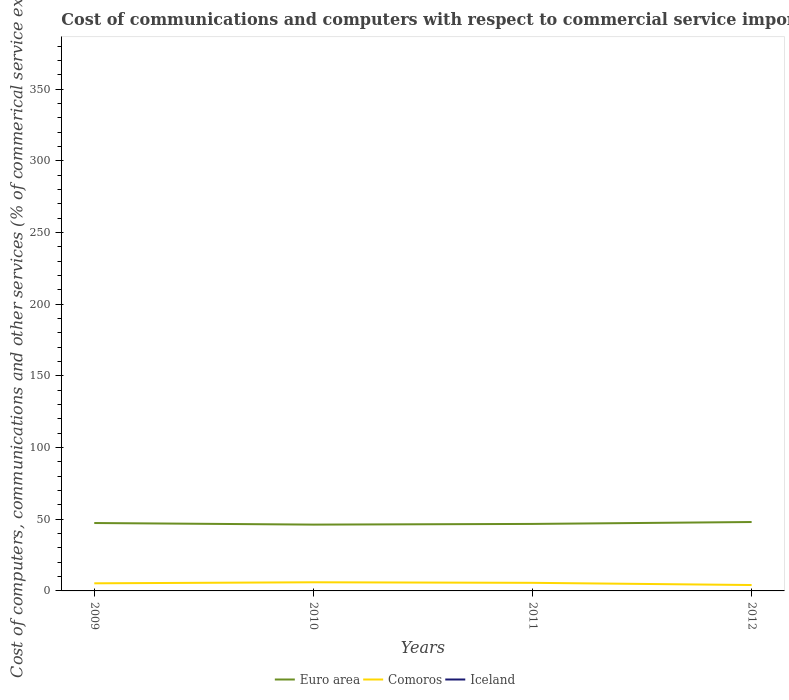Does the line corresponding to Iceland intersect with the line corresponding to Euro area?
Keep it short and to the point. No. Across all years, what is the maximum cost of communications and computers in Iceland?
Provide a short and direct response. 0. What is the total cost of communications and computers in Euro area in the graph?
Offer a very short reply. -0.49. What is the difference between the highest and the second highest cost of communications and computers in Comoros?
Your answer should be very brief. 1.92. Is the cost of communications and computers in Iceland strictly greater than the cost of communications and computers in Comoros over the years?
Offer a very short reply. Yes. How many lines are there?
Your response must be concise. 2. What is the difference between two consecutive major ticks on the Y-axis?
Give a very brief answer. 50. Are the values on the major ticks of Y-axis written in scientific E-notation?
Keep it short and to the point. No. Does the graph contain any zero values?
Keep it short and to the point. Yes. Does the graph contain grids?
Ensure brevity in your answer.  No. Where does the legend appear in the graph?
Offer a very short reply. Bottom center. How many legend labels are there?
Provide a short and direct response. 3. How are the legend labels stacked?
Keep it short and to the point. Horizontal. What is the title of the graph?
Your answer should be compact. Cost of communications and computers with respect to commercial service imports. What is the label or title of the Y-axis?
Your answer should be very brief. Cost of computers, communications and other services (% of commerical service exports). What is the Cost of computers, communications and other services (% of commerical service exports) of Euro area in 2009?
Make the answer very short. 47.36. What is the Cost of computers, communications and other services (% of commerical service exports) in Comoros in 2009?
Make the answer very short. 5.31. What is the Cost of computers, communications and other services (% of commerical service exports) in Iceland in 2009?
Your answer should be very brief. 0. What is the Cost of computers, communications and other services (% of commerical service exports) in Euro area in 2010?
Your answer should be compact. 46.25. What is the Cost of computers, communications and other services (% of commerical service exports) of Comoros in 2010?
Give a very brief answer. 6.03. What is the Cost of computers, communications and other services (% of commerical service exports) in Iceland in 2010?
Give a very brief answer. 0. What is the Cost of computers, communications and other services (% of commerical service exports) in Euro area in 2011?
Ensure brevity in your answer.  46.73. What is the Cost of computers, communications and other services (% of commerical service exports) of Comoros in 2011?
Provide a short and direct response. 5.64. What is the Cost of computers, communications and other services (% of commerical service exports) of Euro area in 2012?
Make the answer very short. 48.05. What is the Cost of computers, communications and other services (% of commerical service exports) in Comoros in 2012?
Provide a succinct answer. 4.11. Across all years, what is the maximum Cost of computers, communications and other services (% of commerical service exports) in Euro area?
Your answer should be very brief. 48.05. Across all years, what is the maximum Cost of computers, communications and other services (% of commerical service exports) in Comoros?
Provide a short and direct response. 6.03. Across all years, what is the minimum Cost of computers, communications and other services (% of commerical service exports) of Euro area?
Provide a succinct answer. 46.25. Across all years, what is the minimum Cost of computers, communications and other services (% of commerical service exports) in Comoros?
Your response must be concise. 4.11. What is the total Cost of computers, communications and other services (% of commerical service exports) of Euro area in the graph?
Ensure brevity in your answer.  188.39. What is the total Cost of computers, communications and other services (% of commerical service exports) of Comoros in the graph?
Keep it short and to the point. 21.09. What is the difference between the Cost of computers, communications and other services (% of commerical service exports) in Euro area in 2009 and that in 2010?
Ensure brevity in your answer.  1.11. What is the difference between the Cost of computers, communications and other services (% of commerical service exports) in Comoros in 2009 and that in 2010?
Give a very brief answer. -0.72. What is the difference between the Cost of computers, communications and other services (% of commerical service exports) of Euro area in 2009 and that in 2011?
Give a very brief answer. 0.62. What is the difference between the Cost of computers, communications and other services (% of commerical service exports) of Comoros in 2009 and that in 2011?
Provide a succinct answer. -0.33. What is the difference between the Cost of computers, communications and other services (% of commerical service exports) in Euro area in 2009 and that in 2012?
Offer a very short reply. -0.7. What is the difference between the Cost of computers, communications and other services (% of commerical service exports) of Comoros in 2009 and that in 2012?
Offer a terse response. 1.2. What is the difference between the Cost of computers, communications and other services (% of commerical service exports) of Euro area in 2010 and that in 2011?
Your response must be concise. -0.49. What is the difference between the Cost of computers, communications and other services (% of commerical service exports) of Comoros in 2010 and that in 2011?
Your answer should be very brief. 0.39. What is the difference between the Cost of computers, communications and other services (% of commerical service exports) in Euro area in 2010 and that in 2012?
Provide a succinct answer. -1.81. What is the difference between the Cost of computers, communications and other services (% of commerical service exports) in Comoros in 2010 and that in 2012?
Offer a terse response. 1.92. What is the difference between the Cost of computers, communications and other services (% of commerical service exports) in Euro area in 2011 and that in 2012?
Keep it short and to the point. -1.32. What is the difference between the Cost of computers, communications and other services (% of commerical service exports) of Comoros in 2011 and that in 2012?
Ensure brevity in your answer.  1.53. What is the difference between the Cost of computers, communications and other services (% of commerical service exports) of Euro area in 2009 and the Cost of computers, communications and other services (% of commerical service exports) of Comoros in 2010?
Provide a succinct answer. 41.33. What is the difference between the Cost of computers, communications and other services (% of commerical service exports) in Euro area in 2009 and the Cost of computers, communications and other services (% of commerical service exports) in Comoros in 2011?
Make the answer very short. 41.72. What is the difference between the Cost of computers, communications and other services (% of commerical service exports) of Euro area in 2009 and the Cost of computers, communications and other services (% of commerical service exports) of Comoros in 2012?
Provide a succinct answer. 43.25. What is the difference between the Cost of computers, communications and other services (% of commerical service exports) in Euro area in 2010 and the Cost of computers, communications and other services (% of commerical service exports) in Comoros in 2011?
Ensure brevity in your answer.  40.61. What is the difference between the Cost of computers, communications and other services (% of commerical service exports) in Euro area in 2010 and the Cost of computers, communications and other services (% of commerical service exports) in Comoros in 2012?
Your answer should be compact. 42.13. What is the difference between the Cost of computers, communications and other services (% of commerical service exports) in Euro area in 2011 and the Cost of computers, communications and other services (% of commerical service exports) in Comoros in 2012?
Offer a very short reply. 42.62. What is the average Cost of computers, communications and other services (% of commerical service exports) of Euro area per year?
Provide a short and direct response. 47.1. What is the average Cost of computers, communications and other services (% of commerical service exports) of Comoros per year?
Your answer should be very brief. 5.27. What is the average Cost of computers, communications and other services (% of commerical service exports) in Iceland per year?
Keep it short and to the point. 0. In the year 2009, what is the difference between the Cost of computers, communications and other services (% of commerical service exports) of Euro area and Cost of computers, communications and other services (% of commerical service exports) of Comoros?
Ensure brevity in your answer.  42.05. In the year 2010, what is the difference between the Cost of computers, communications and other services (% of commerical service exports) of Euro area and Cost of computers, communications and other services (% of commerical service exports) of Comoros?
Your response must be concise. 40.22. In the year 2011, what is the difference between the Cost of computers, communications and other services (% of commerical service exports) of Euro area and Cost of computers, communications and other services (% of commerical service exports) of Comoros?
Give a very brief answer. 41.1. In the year 2012, what is the difference between the Cost of computers, communications and other services (% of commerical service exports) of Euro area and Cost of computers, communications and other services (% of commerical service exports) of Comoros?
Your answer should be compact. 43.94. What is the ratio of the Cost of computers, communications and other services (% of commerical service exports) in Euro area in 2009 to that in 2010?
Make the answer very short. 1.02. What is the ratio of the Cost of computers, communications and other services (% of commerical service exports) in Comoros in 2009 to that in 2010?
Give a very brief answer. 0.88. What is the ratio of the Cost of computers, communications and other services (% of commerical service exports) in Euro area in 2009 to that in 2011?
Your answer should be very brief. 1.01. What is the ratio of the Cost of computers, communications and other services (% of commerical service exports) in Comoros in 2009 to that in 2011?
Make the answer very short. 0.94. What is the ratio of the Cost of computers, communications and other services (% of commerical service exports) of Euro area in 2009 to that in 2012?
Your answer should be very brief. 0.99. What is the ratio of the Cost of computers, communications and other services (% of commerical service exports) in Comoros in 2009 to that in 2012?
Offer a very short reply. 1.29. What is the ratio of the Cost of computers, communications and other services (% of commerical service exports) of Euro area in 2010 to that in 2011?
Offer a terse response. 0.99. What is the ratio of the Cost of computers, communications and other services (% of commerical service exports) of Comoros in 2010 to that in 2011?
Offer a terse response. 1.07. What is the ratio of the Cost of computers, communications and other services (% of commerical service exports) in Euro area in 2010 to that in 2012?
Provide a short and direct response. 0.96. What is the ratio of the Cost of computers, communications and other services (% of commerical service exports) in Comoros in 2010 to that in 2012?
Offer a terse response. 1.47. What is the ratio of the Cost of computers, communications and other services (% of commerical service exports) in Euro area in 2011 to that in 2012?
Your answer should be very brief. 0.97. What is the ratio of the Cost of computers, communications and other services (% of commerical service exports) of Comoros in 2011 to that in 2012?
Offer a terse response. 1.37. What is the difference between the highest and the second highest Cost of computers, communications and other services (% of commerical service exports) in Euro area?
Provide a succinct answer. 0.7. What is the difference between the highest and the second highest Cost of computers, communications and other services (% of commerical service exports) of Comoros?
Offer a terse response. 0.39. What is the difference between the highest and the lowest Cost of computers, communications and other services (% of commerical service exports) in Euro area?
Ensure brevity in your answer.  1.81. What is the difference between the highest and the lowest Cost of computers, communications and other services (% of commerical service exports) in Comoros?
Ensure brevity in your answer.  1.92. 